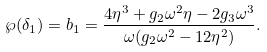<formula> <loc_0><loc_0><loc_500><loc_500>\wp ( \delta _ { 1 } ) = b _ { 1 } = \frac { 4 \eta ^ { 3 } + g _ { 2 } \omega ^ { 2 } \eta - 2 g _ { 3 } \omega ^ { 3 } } { \omega ( g _ { 2 } \omega ^ { 2 } - 1 2 \eta ^ { 2 } ) } .</formula> 